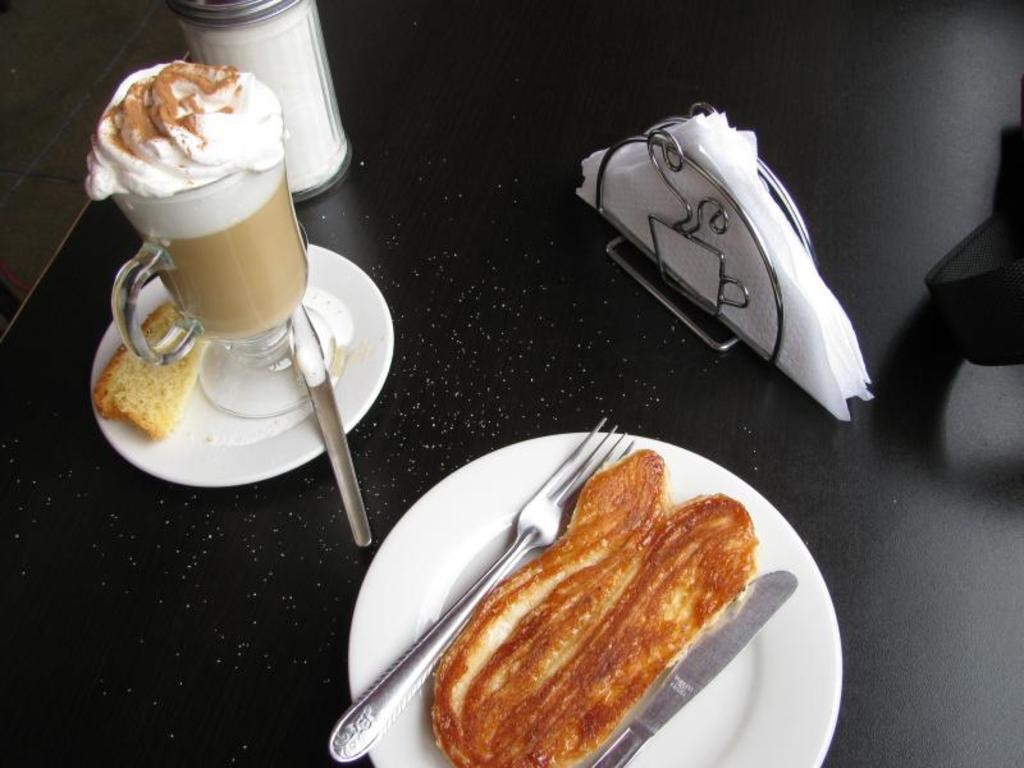What is on the plate that is visible in the image? There is a plate with food in the image. What utensils are present in the image? There is a knife and a fork in the image. What is the cup in the image used for? The cup in the image is likely used for holding a beverage. What item might be used for cleaning or wiping in the image? Tissues are present in the image for cleaning or wiping. What is the color of the table in the image? The table in the image is black. Can you see a kitten playing with a roll on the table in the image? There is no kitten or roll present in the image. Is there a bat hanging from the ceiling in the image? There is no bat present in the image. 